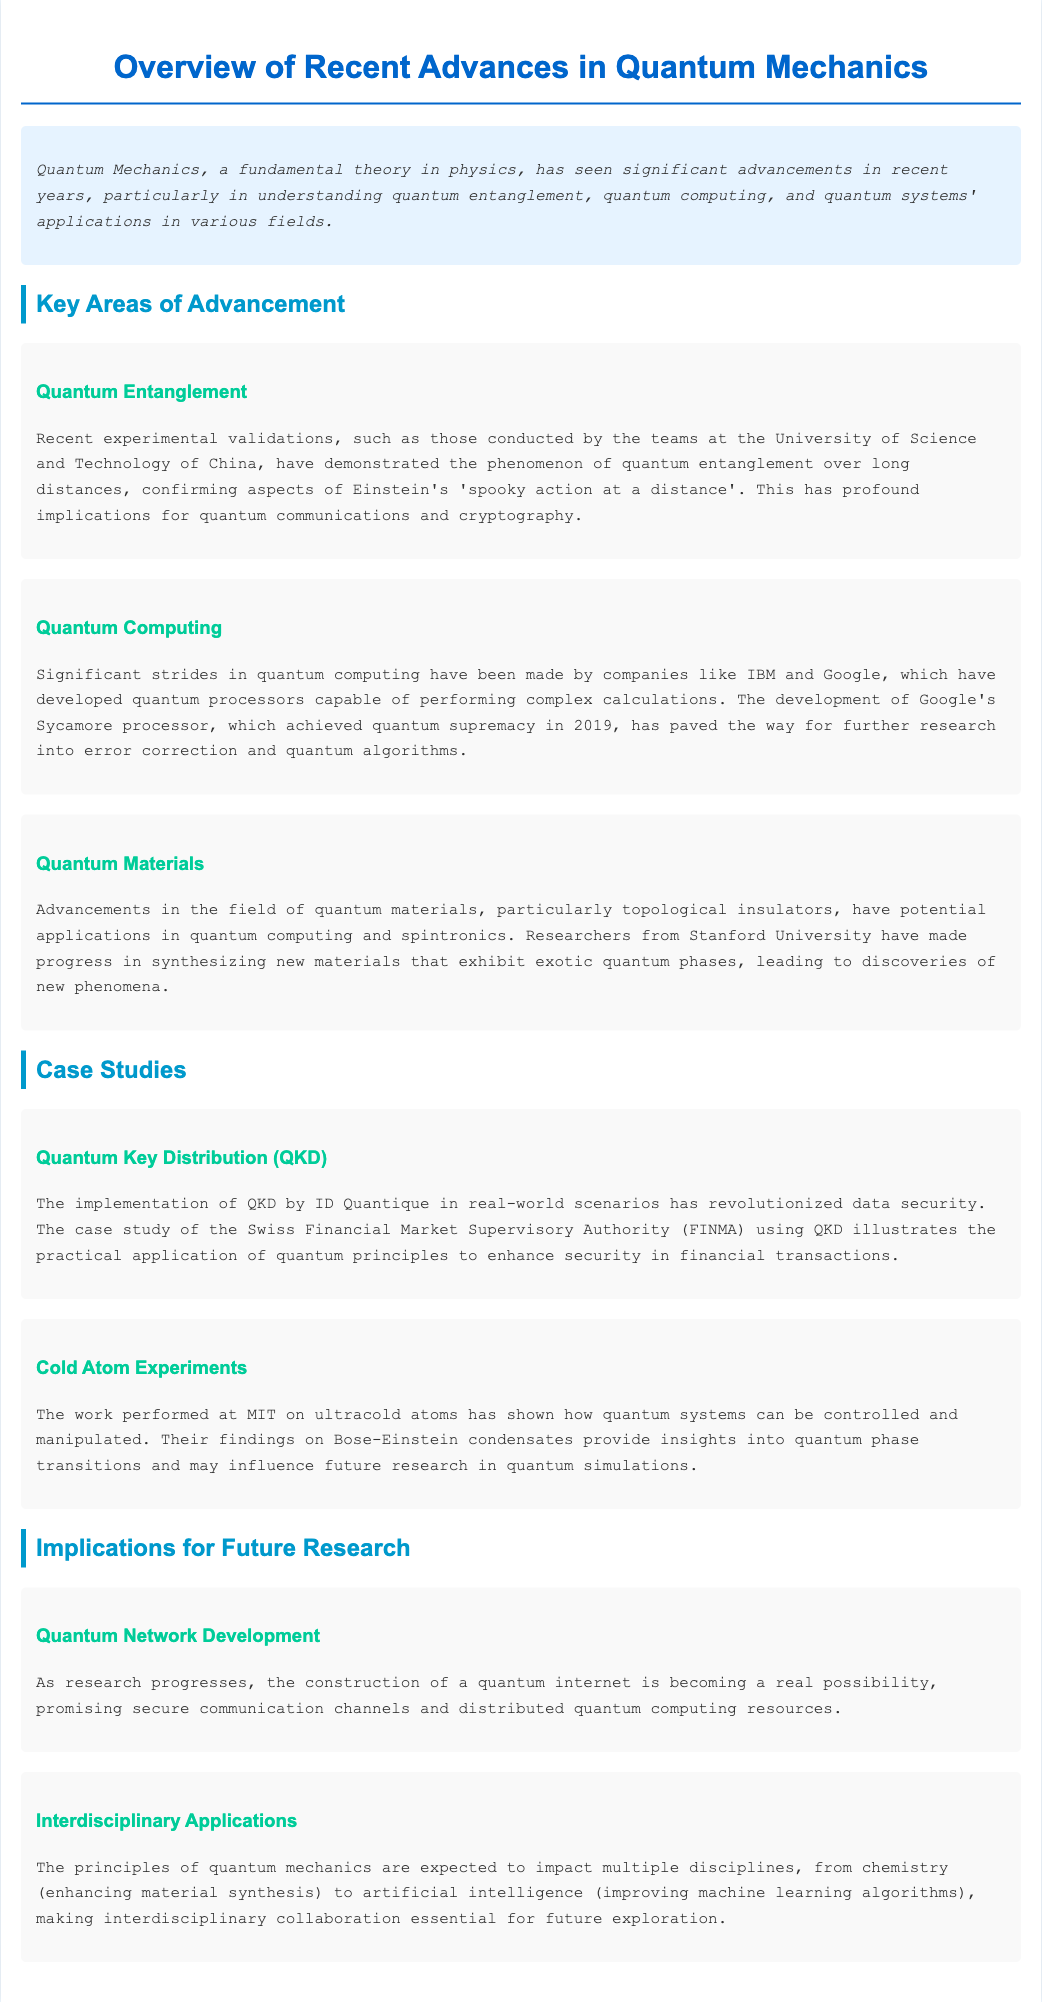What is the title of the document? The title is provided in the `<title>` tag of the HTML, which is "Quantum Mechanics Advances: A Physicist's Guide".
Answer: Quantum Mechanics Advances: A Physicist's Guide Who conducted experiments on quantum entanglement? The document states that the experiments were conducted by teams at the University of Science and Technology of China.
Answer: University of Science and Technology of China What is the name of Google's quantum processor that achieved quantum supremacy? The document mentions that Google's Sycamore processor achieved quantum supremacy in 2019.
Answer: Sycamore Which type of materials has seen advancements in quantum mechanics? The document specifies advancements particularly in the field of quantum materials, including topological insulators.
Answer: Topological insulators What is one implication for future research mentioned in the document? The document lists the construction of a quantum internet as a significant implication for future research.
Answer: Quantum internet What application case study is highlighted in the document? The document features Quantum Key Distribution (QKD) as a significant case study.
Answer: Quantum Key Distribution (QKD) Which university performed work on ultracold atoms? The document states that work on ultracold atoms was performed at MIT.
Answer: MIT What is a potential impact of quantum principles on interdisciplinary applications? The document mentions that quantum principles are expected to enhance material synthesis in chemistry.
Answer: Enhanced material synthesis 